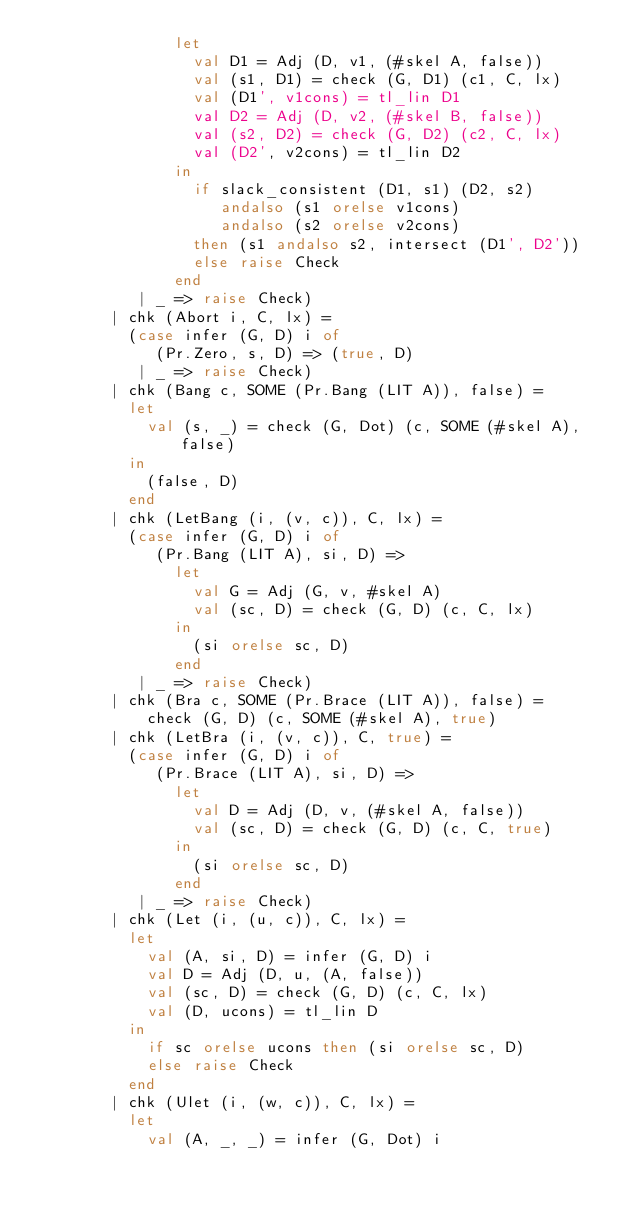<code> <loc_0><loc_0><loc_500><loc_500><_SML_>               let
                 val D1 = Adj (D, v1, (#skel A, false))
                 val (s1, D1) = check (G, D1) (c1, C, lx)
                 val (D1', v1cons) = tl_lin D1
                 val D2 = Adj (D, v2, (#skel B, false))
                 val (s2, D2) = check (G, D2) (c2, C, lx)
                 val (D2', v2cons) = tl_lin D2
               in
                 if slack_consistent (D1, s1) (D2, s2)
                    andalso (s1 orelse v1cons)
                    andalso (s2 orelse v2cons)
                 then (s1 andalso s2, intersect (D1', D2'))
                 else raise Check
               end
           | _ => raise Check)
        | chk (Abort i, C, lx) =
          (case infer (G, D) i of
             (Pr.Zero, s, D) => (true, D)
           | _ => raise Check)
        | chk (Bang c, SOME (Pr.Bang (LIT A)), false) =
          let
            val (s, _) = check (G, Dot) (c, SOME (#skel A), false)
          in
            (false, D)
          end
        | chk (LetBang (i, (v, c)), C, lx) = 
          (case infer (G, D) i of
             (Pr.Bang (LIT A), si, D) =>
               let
                 val G = Adj (G, v, #skel A)
                 val (sc, D) = check (G, D) (c, C, lx)
               in
                 (si orelse sc, D)
               end
           | _ => raise Check)
        | chk (Bra c, SOME (Pr.Brace (LIT A)), false) = 
            check (G, D) (c, SOME (#skel A), true)
        | chk (LetBra (i, (v, c)), C, true) = 
          (case infer (G, D) i of
             (Pr.Brace (LIT A), si, D) =>
               let
                 val D = Adj (D, v, (#skel A, false))
                 val (sc, D) = check (G, D) (c, C, true)
               in
                 (si orelse sc, D)
               end
           | _ => raise Check)
        | chk (Let (i, (u, c)), C, lx) = 
          let
            val (A, si, D) = infer (G, D) i
            val D = Adj (D, u, (A, false))
            val (sc, D) = check (G, D) (c, C, lx)
            val (D, ucons) = tl_lin D
          in
            if sc orelse ucons then (si orelse sc, D)
            else raise Check
          end
        | chk (Ulet (i, (w, c)), C, lx) = 
          let
            val (A, _, _) = infer (G, Dot) i</code> 